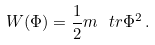Convert formula to latex. <formula><loc_0><loc_0><loc_500><loc_500>W ( \Phi ) = \frac { 1 } { 2 } m \ t r \Phi ^ { 2 } \, .</formula> 